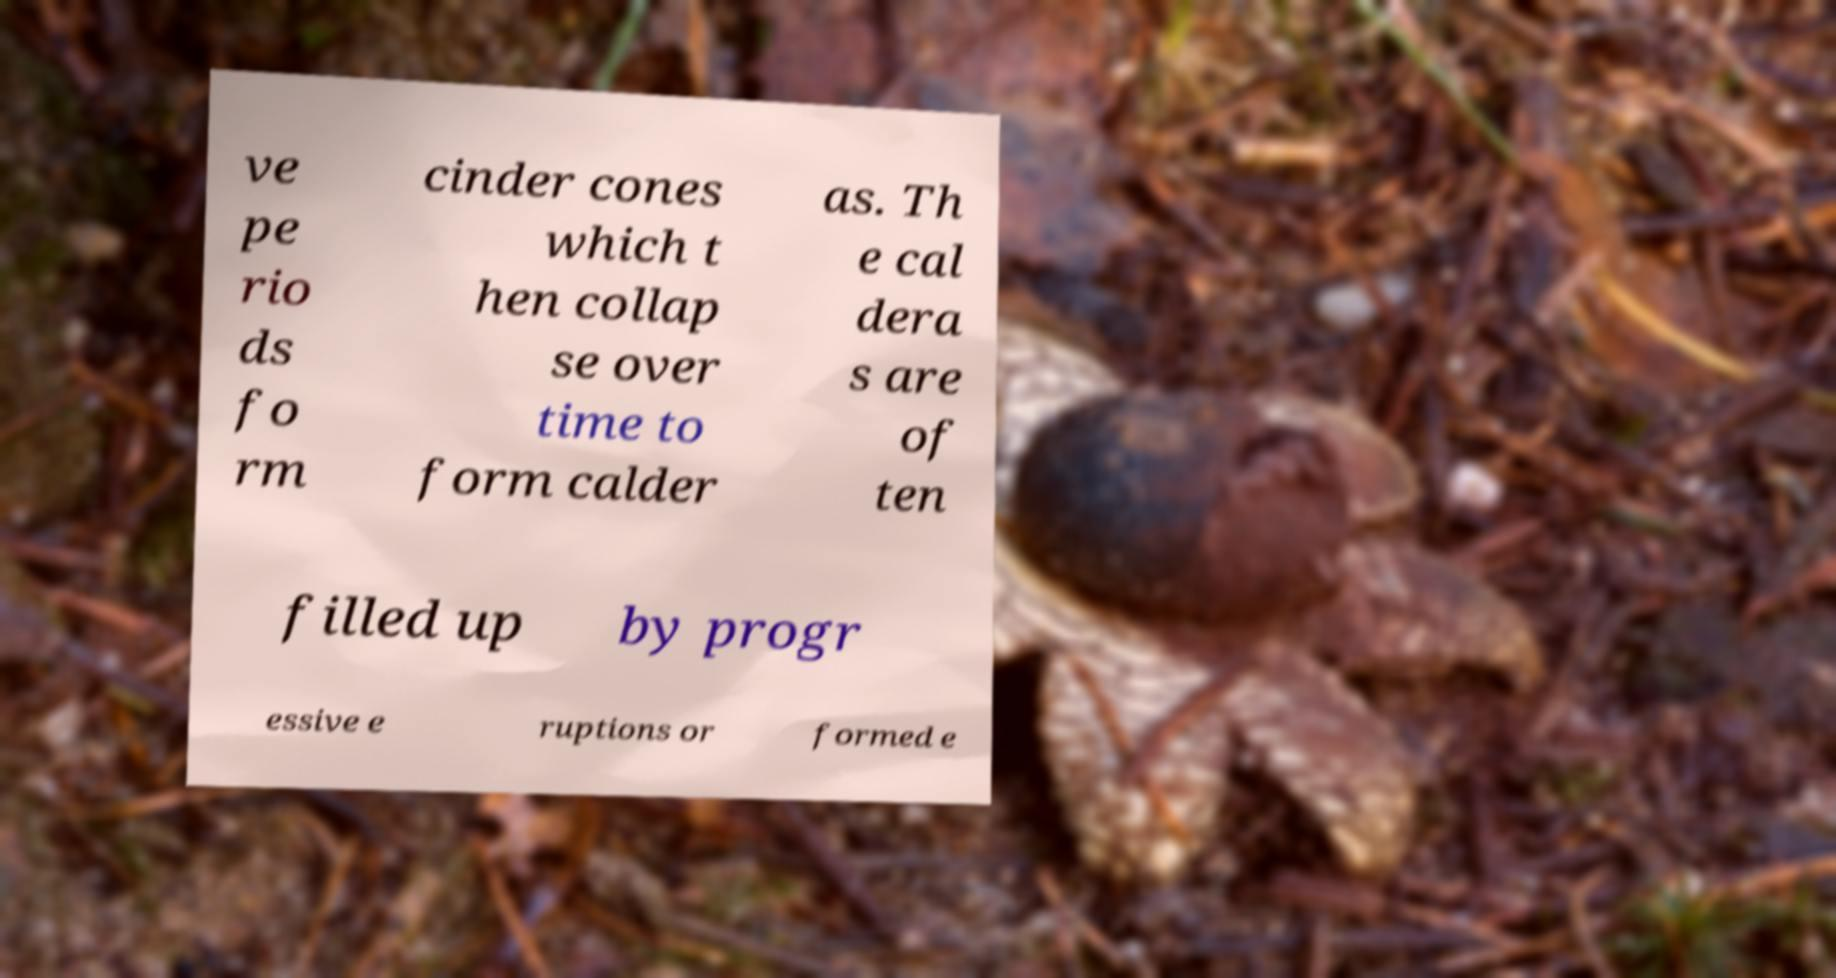For documentation purposes, I need the text within this image transcribed. Could you provide that? ve pe rio ds fo rm cinder cones which t hen collap se over time to form calder as. Th e cal dera s are of ten filled up by progr essive e ruptions or formed e 